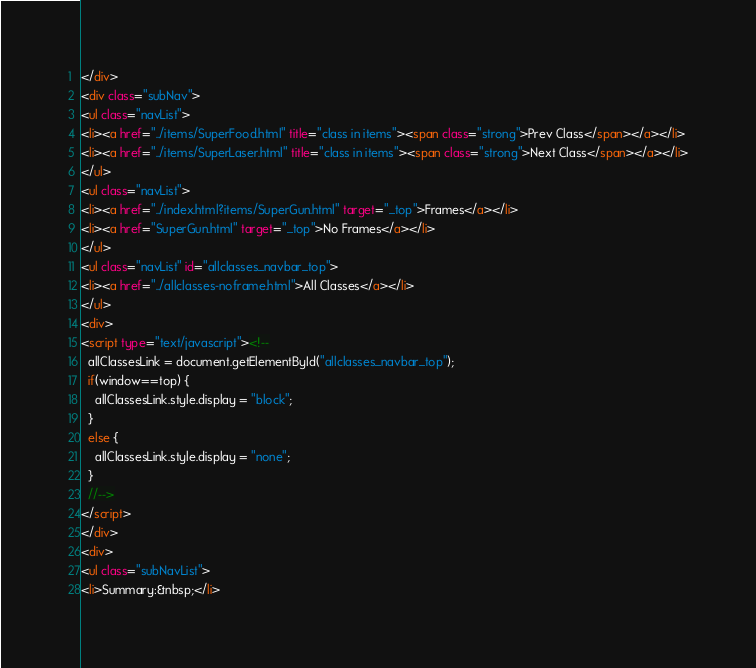Convert code to text. <code><loc_0><loc_0><loc_500><loc_500><_HTML_></div>
<div class="subNav">
<ul class="navList">
<li><a href="../items/SuperFood.html" title="class in items"><span class="strong">Prev Class</span></a></li>
<li><a href="../items/SuperLaser.html" title="class in items"><span class="strong">Next Class</span></a></li>
</ul>
<ul class="navList">
<li><a href="../index.html?items/SuperGun.html" target="_top">Frames</a></li>
<li><a href="SuperGun.html" target="_top">No Frames</a></li>
</ul>
<ul class="navList" id="allclasses_navbar_top">
<li><a href="../allclasses-noframe.html">All Classes</a></li>
</ul>
<div>
<script type="text/javascript"><!--
  allClassesLink = document.getElementById("allclasses_navbar_top");
  if(window==top) {
    allClassesLink.style.display = "block";
  }
  else {
    allClassesLink.style.display = "none";
  }
  //-->
</script>
</div>
<div>
<ul class="subNavList">
<li>Summary:&nbsp;</li></code> 